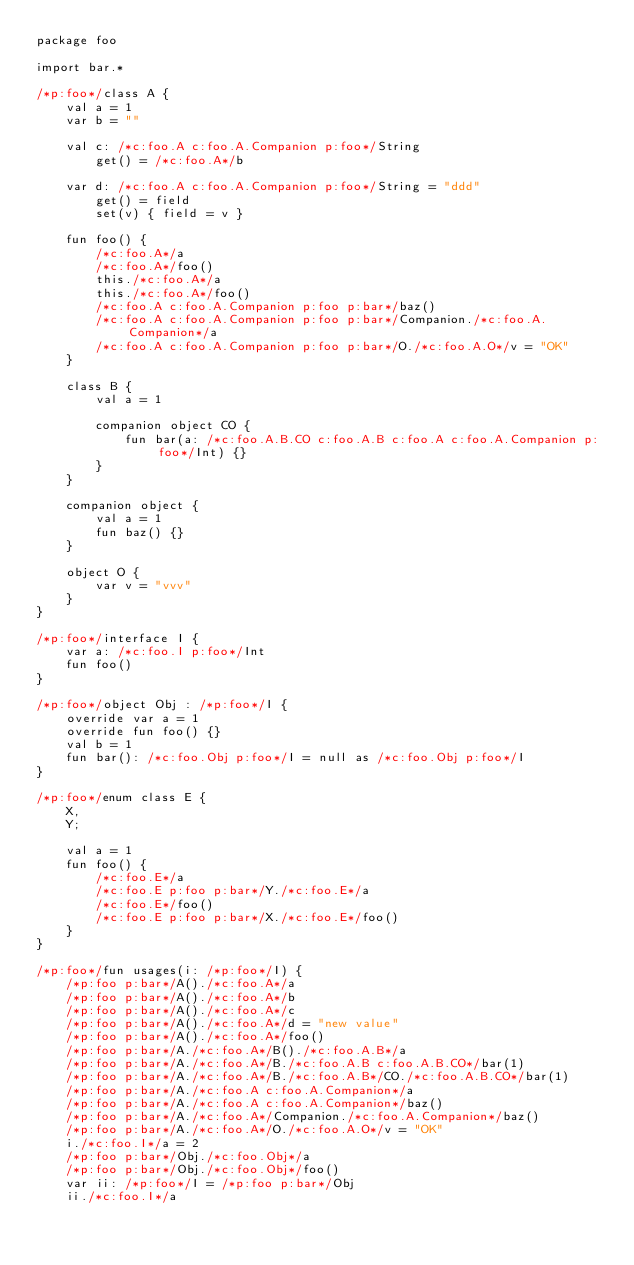<code> <loc_0><loc_0><loc_500><loc_500><_Kotlin_>package foo

import bar.*

/*p:foo*/class A {
    val a = 1
    var b = ""

    val c: /*c:foo.A c:foo.A.Companion p:foo*/String
        get() = /*c:foo.A*/b

    var d: /*c:foo.A c:foo.A.Companion p:foo*/String = "ddd"
        get() = field
        set(v) { field = v }

    fun foo() {
        /*c:foo.A*/a
        /*c:foo.A*/foo()
        this./*c:foo.A*/a
        this./*c:foo.A*/foo()
        /*c:foo.A c:foo.A.Companion p:foo p:bar*/baz()
        /*c:foo.A c:foo.A.Companion p:foo p:bar*/Companion./*c:foo.A.Companion*/a
        /*c:foo.A c:foo.A.Companion p:foo p:bar*/O./*c:foo.A.O*/v = "OK"
    }

    class B {
        val a = 1

        companion object CO {
            fun bar(a: /*c:foo.A.B.CO c:foo.A.B c:foo.A c:foo.A.Companion p:foo*/Int) {}
        }
    }

    companion object {
        val a = 1
        fun baz() {}
    }

    object O {
        var v = "vvv"
    }
}

/*p:foo*/interface I {
    var a: /*c:foo.I p:foo*/Int
    fun foo()
}

/*p:foo*/object Obj : /*p:foo*/I {
    override var a = 1
    override fun foo() {}
    val b = 1
    fun bar(): /*c:foo.Obj p:foo*/I = null as /*c:foo.Obj p:foo*/I
}

/*p:foo*/enum class E {
    X,
    Y;

    val a = 1
    fun foo() {
        /*c:foo.E*/a
        /*c:foo.E p:foo p:bar*/Y./*c:foo.E*/a
        /*c:foo.E*/foo()
        /*c:foo.E p:foo p:bar*/X./*c:foo.E*/foo()
    }
}

/*p:foo*/fun usages(i: /*p:foo*/I) {
    /*p:foo p:bar*/A()./*c:foo.A*/a
    /*p:foo p:bar*/A()./*c:foo.A*/b
    /*p:foo p:bar*/A()./*c:foo.A*/c
    /*p:foo p:bar*/A()./*c:foo.A*/d = "new value"
    /*p:foo p:bar*/A()./*c:foo.A*/foo()
    /*p:foo p:bar*/A./*c:foo.A*/B()./*c:foo.A.B*/a
    /*p:foo p:bar*/A./*c:foo.A*/B./*c:foo.A.B c:foo.A.B.CO*/bar(1)
    /*p:foo p:bar*/A./*c:foo.A*/B./*c:foo.A.B*/CO./*c:foo.A.B.CO*/bar(1)
    /*p:foo p:bar*/A./*c:foo.A c:foo.A.Companion*/a
    /*p:foo p:bar*/A./*c:foo.A c:foo.A.Companion*/baz()
    /*p:foo p:bar*/A./*c:foo.A*/Companion./*c:foo.A.Companion*/baz()
    /*p:foo p:bar*/A./*c:foo.A*/O./*c:foo.A.O*/v = "OK"
    i./*c:foo.I*/a = 2
    /*p:foo p:bar*/Obj./*c:foo.Obj*/a
    /*p:foo p:bar*/Obj./*c:foo.Obj*/foo()
    var ii: /*p:foo*/I = /*p:foo p:bar*/Obj
    ii./*c:foo.I*/a</code> 